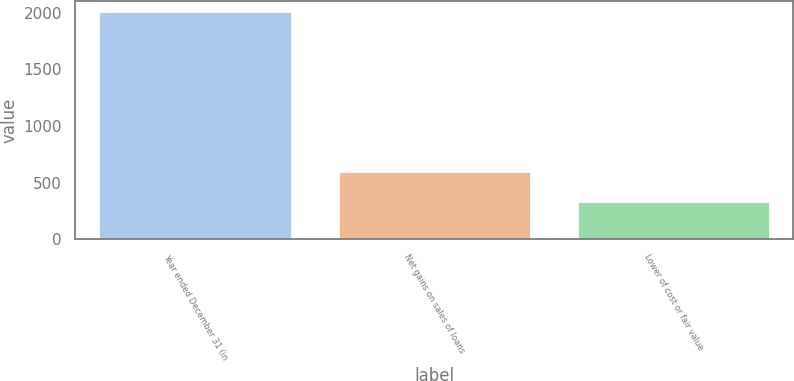<chart> <loc_0><loc_0><loc_500><loc_500><bar_chart><fcel>Year ended December 31 (in<fcel>Net gains on sales of loans<fcel>Lower of cost or fair value<nl><fcel>2005<fcel>596<fcel>332<nl></chart> 